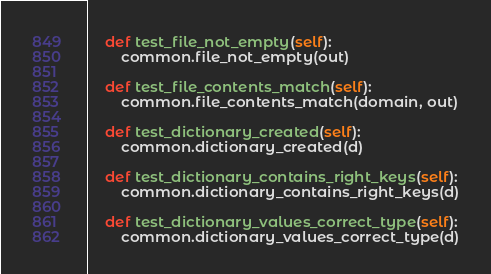<code> <loc_0><loc_0><loc_500><loc_500><_Python_>    def test_file_not_empty(self):
        common.file_not_empty(out)

    def test_file_contents_match(self):
        common.file_contents_match(domain, out)

    def test_dictionary_created(self):
        common.dictionary_created(d)

    def test_dictionary_contains_right_keys(self):
        common.dictionary_contains_right_keys(d)

    def test_dictionary_values_correct_type(self):
        common.dictionary_values_correct_type(d)
</code> 